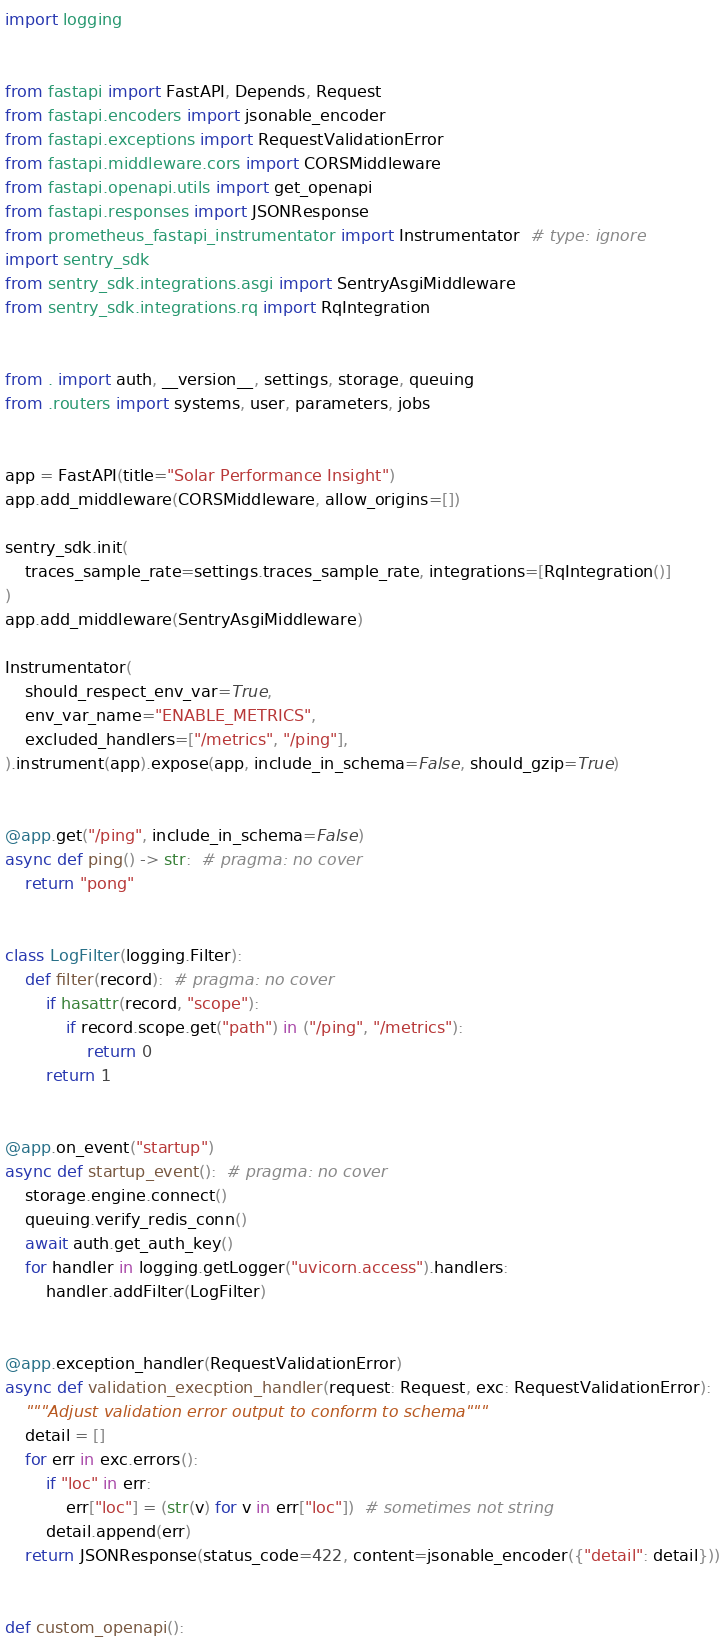<code> <loc_0><loc_0><loc_500><loc_500><_Python_>import logging


from fastapi import FastAPI, Depends, Request
from fastapi.encoders import jsonable_encoder
from fastapi.exceptions import RequestValidationError
from fastapi.middleware.cors import CORSMiddleware
from fastapi.openapi.utils import get_openapi
from fastapi.responses import JSONResponse
from prometheus_fastapi_instrumentator import Instrumentator  # type: ignore
import sentry_sdk
from sentry_sdk.integrations.asgi import SentryAsgiMiddleware
from sentry_sdk.integrations.rq import RqIntegration


from . import auth, __version__, settings, storage, queuing
from .routers import systems, user, parameters, jobs


app = FastAPI(title="Solar Performance Insight")
app.add_middleware(CORSMiddleware, allow_origins=[])

sentry_sdk.init(
    traces_sample_rate=settings.traces_sample_rate, integrations=[RqIntegration()]
)
app.add_middleware(SentryAsgiMiddleware)

Instrumentator(
    should_respect_env_var=True,
    env_var_name="ENABLE_METRICS",
    excluded_handlers=["/metrics", "/ping"],
).instrument(app).expose(app, include_in_schema=False, should_gzip=True)


@app.get("/ping", include_in_schema=False)
async def ping() -> str:  # pragma: no cover
    return "pong"


class LogFilter(logging.Filter):
    def filter(record):  # pragma: no cover
        if hasattr(record, "scope"):
            if record.scope.get("path") in ("/ping", "/metrics"):
                return 0
        return 1


@app.on_event("startup")
async def startup_event():  # pragma: no cover
    storage.engine.connect()
    queuing.verify_redis_conn()
    await auth.get_auth_key()
    for handler in logging.getLogger("uvicorn.access").handlers:
        handler.addFilter(LogFilter)


@app.exception_handler(RequestValidationError)
async def validation_execption_handler(request: Request, exc: RequestValidationError):
    """Adjust validation error output to conform to schema"""
    detail = []
    for err in exc.errors():
        if "loc" in err:
            err["loc"] = (str(v) for v in err["loc"])  # sometimes not string
        detail.append(err)
    return JSONResponse(status_code=422, content=jsonable_encoder({"detail": detail}))


def custom_openapi():</code> 